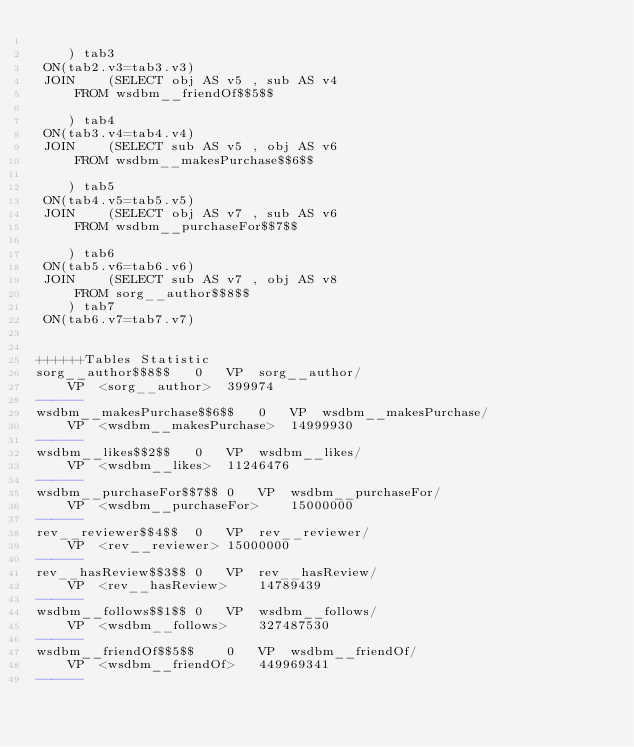Convert code to text. <code><loc_0><loc_0><loc_500><loc_500><_SQL_>	
	) tab3
 ON(tab2.v3=tab3.v3)
 JOIN    (SELECT obj AS v5 , sub AS v4 
	 FROM wsdbm__friendOf$$5$$
	
	) tab4
 ON(tab3.v4=tab4.v4)
 JOIN    (SELECT sub AS v5 , obj AS v6 
	 FROM wsdbm__makesPurchase$$6$$
	
	) tab5
 ON(tab4.v5=tab5.v5)
 JOIN    (SELECT obj AS v7 , sub AS v6 
	 FROM wsdbm__purchaseFor$$7$$
	
	) tab6
 ON(tab5.v6=tab6.v6)
 JOIN    (SELECT sub AS v7 , obj AS v8 
	 FROM sorg__author$$8$$
	) tab7
 ON(tab6.v7=tab7.v7)


++++++Tables Statistic
sorg__author$$8$$	0	VP	sorg__author/
	VP	<sorg__author>	399974
------
wsdbm__makesPurchase$$6$$	0	VP	wsdbm__makesPurchase/
	VP	<wsdbm__makesPurchase>	14999930
------
wsdbm__likes$$2$$	0	VP	wsdbm__likes/
	VP	<wsdbm__likes>	11246476
------
wsdbm__purchaseFor$$7$$	0	VP	wsdbm__purchaseFor/
	VP	<wsdbm__purchaseFor>	15000000
------
rev__reviewer$$4$$	0	VP	rev__reviewer/
	VP	<rev__reviewer>	15000000
------
rev__hasReview$$3$$	0	VP	rev__hasReview/
	VP	<rev__hasReview>	14789439
------
wsdbm__follows$$1$$	0	VP	wsdbm__follows/
	VP	<wsdbm__follows>	327487530
------
wsdbm__friendOf$$5$$	0	VP	wsdbm__friendOf/
	VP	<wsdbm__friendOf>	449969341
------
</code> 